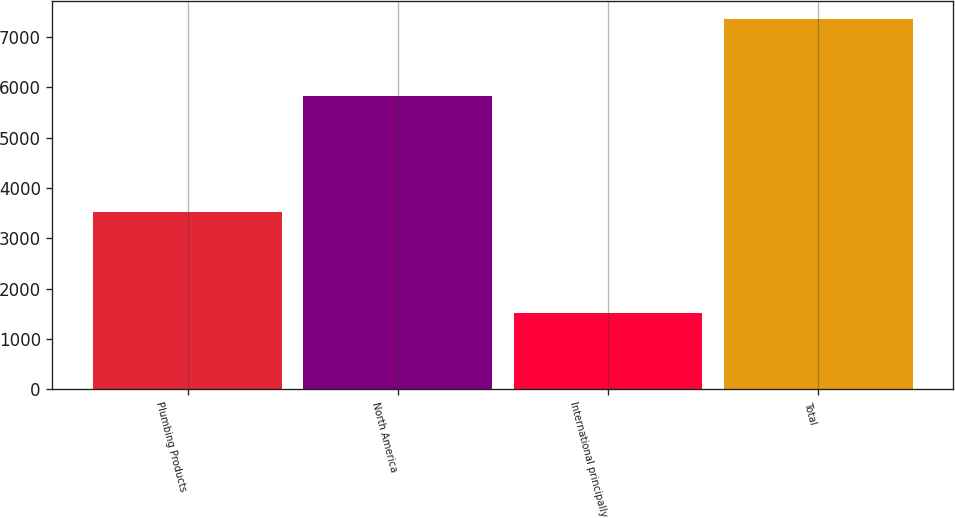Convert chart to OTSL. <chart><loc_0><loc_0><loc_500><loc_500><bar_chart><fcel>Plumbing Products<fcel>North America<fcel>International principally<fcel>Total<nl><fcel>3526<fcel>5834<fcel>1523<fcel>7357<nl></chart> 